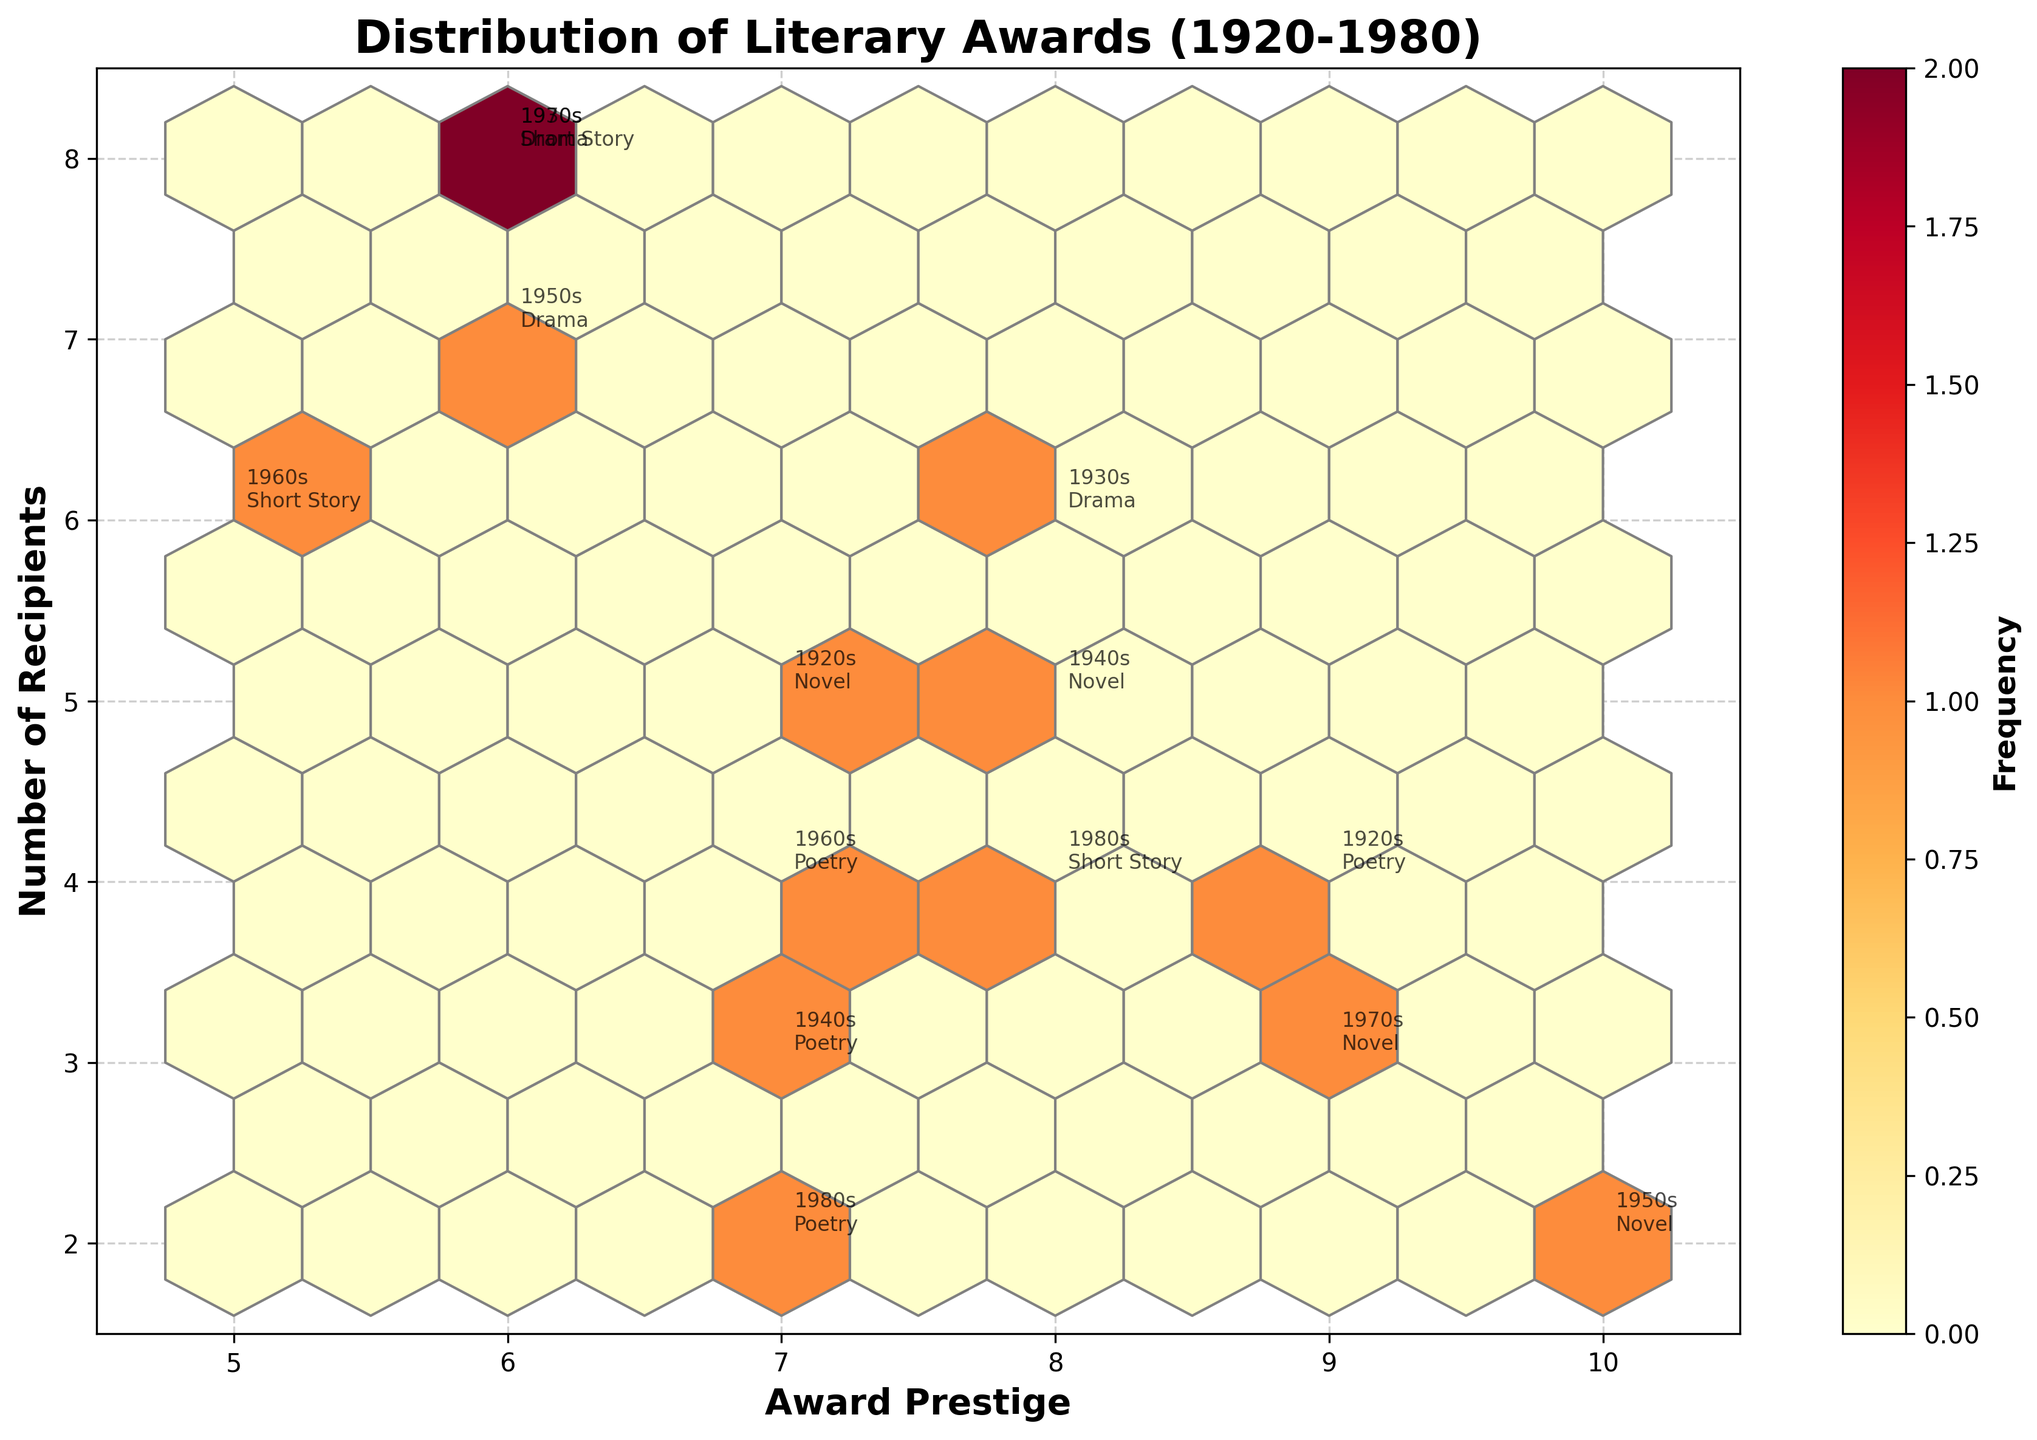What is the title of the figure? The title is usually displayed at the top of the figure. In this plot, it should be located there as well. It reads "Distribution of Literary Awards (1920-1980)"
Answer: Distribution of Literary Awards (1920-1980) What does the color intensity in the hexbin plot indicate? In a hexbin plot, color intensity typically represents the frequency of data points within each hexagon. The color bar shows the frequency scale, with more intense colors indicating higher frequency and lighter colors indicating lower frequency.
Answer: Frequency Which decade has the highest award prestige for a novel? To find the highest award prestige for a novel, locate the data points annotated with 'Novel' on the plot, and check their prestige ratings on the x-axis. The Nobel Prize in Literature in the 1950s has the highest prestige of 10.
Answer: 1950s How many recipients are there for the most prestigious poetry award? First, find the data point with the highest prestige among poetry awards (x-axis). The Pulitzer Prize in the 1920s has a prestige of 9. Then, look at the number of recipients on the y-axis for this award, which is 4.
Answer: 4 Which genre appears most frequently in the 1960s, and how is this determined? Look at the data annotations for the 1960s and count the number of appearances of each genre. The 1960s have annotations for Short Story and Poetry. Both genres appear once.
Answer: Tie between Short Story and Poetry Are there more recipients for Poetry awards or Drama awards over the entire period? Sum the number of recipients for each genre over the decades. Poetry: 4 (1920s) + 3 (1940s) + 4 (1960s) + 2 (1980s) = 13. Drama: 6 (1930s) + 7 (1950s) + 8 (1970s) = 21.
Answer: Drama Which genre has the least overall variance in award prestige? Calculate the variance in prestige ratings for each genre. Poetry: variance of {9, 7, 7, 7}, Drama: variance of {8, 6, 6}, Short Story: variance of {6, 5, 8}, Novel: variance of {7, 8, 10, 9}. Poetry has the least variance.
Answer: Poetry Which decade features the most diverse (widest range) number of recipients for any genre? Identify the number of recipients for each decade and then calculate the range for that decade. The 1930s have ranges from 6 (Drama) to 8 (Short Story), giving a range of 2. The 1950s range from 2 (Novel) to 7 (Drama), giving a range of 5. The 1970s range from 6 (Drama) to 3 (Novel), giving a range of 5. The 1960s range from 6 (Short Story) to 4 (Poetry), giving a range of 2. The 1940s range from 3 (Poetry) to 5 (Novel), giving a range of 2. The 1920s range from 4 (Poetry) to 5 (Novel), giving a range of 1. The 1980s range from 2 (Poetry) to 4 (Short Story), giving a range of 2. The 1950s and 1970s have the widest range of 5.
Answer: 1950s and 1970s 